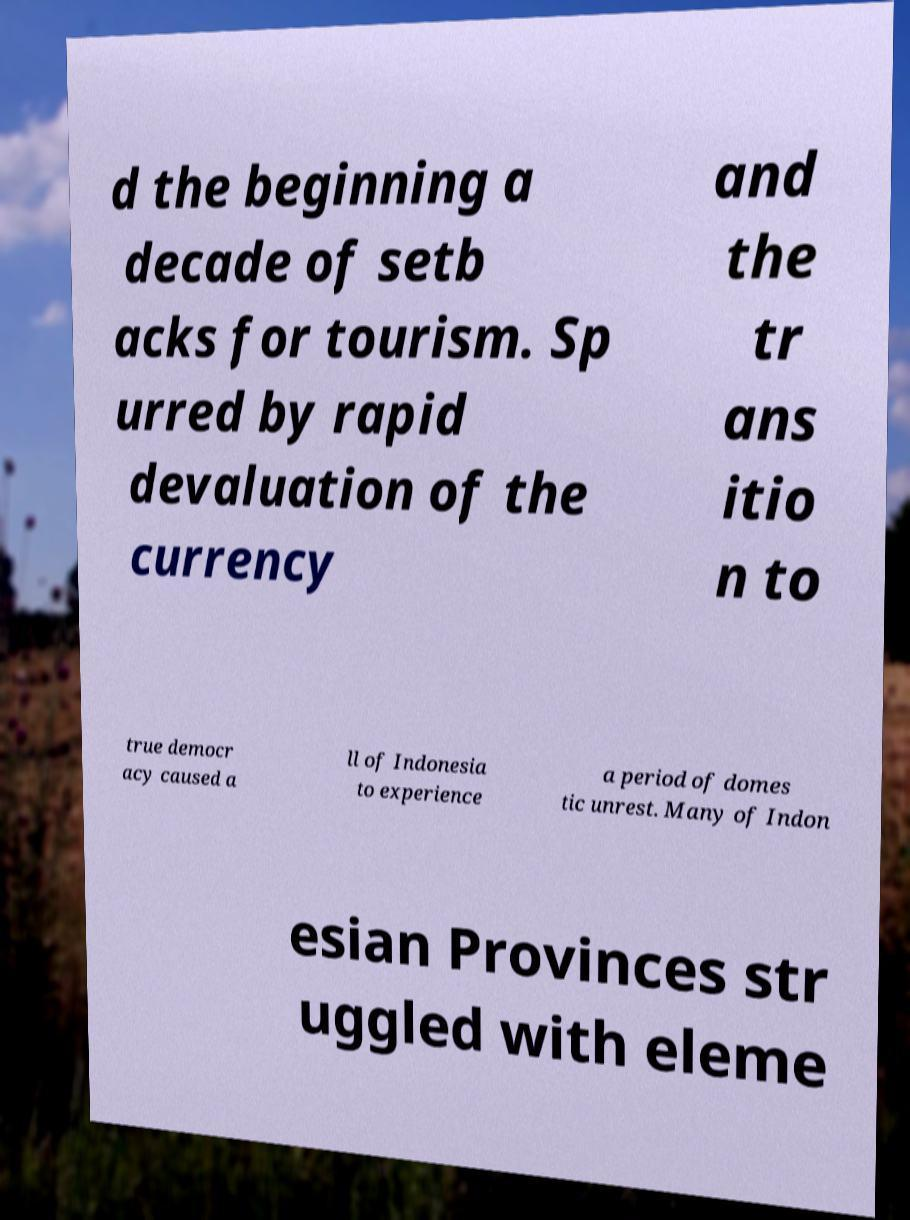I need the written content from this picture converted into text. Can you do that? d the beginning a decade of setb acks for tourism. Sp urred by rapid devaluation of the currency and the tr ans itio n to true democr acy caused a ll of Indonesia to experience a period of domes tic unrest. Many of Indon esian Provinces str uggled with eleme 